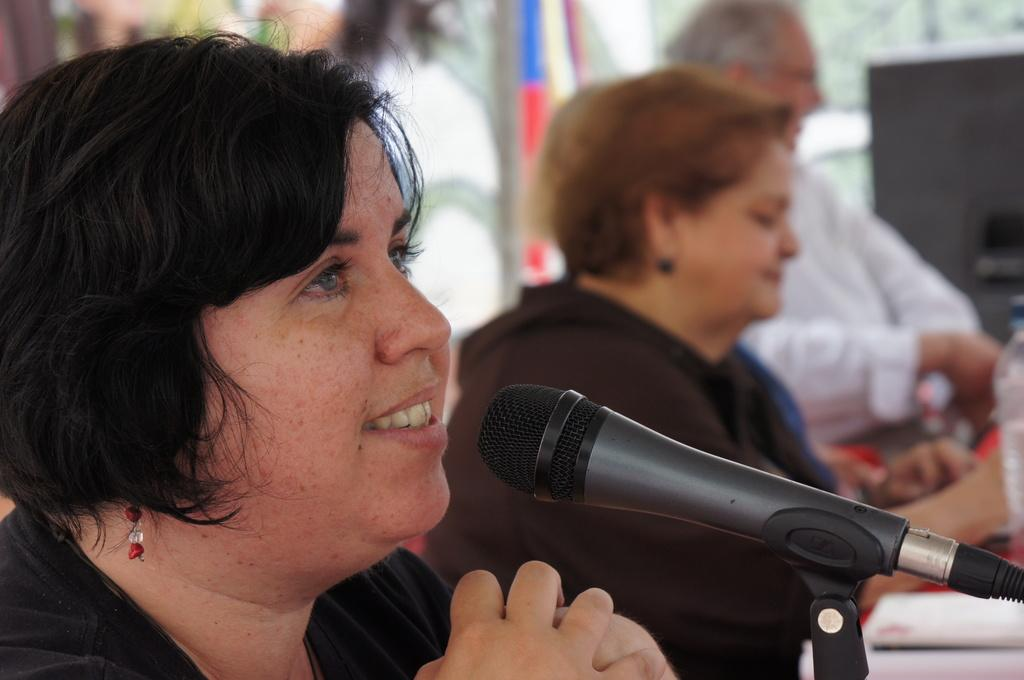Who is present in the image? There is a woman in the image. What is the woman doing in the image? The woman is smiling in the image. What object can be seen near the woman? There is a microphone (mike) in the image. What other item is visible in the image? There is a bottle in the image. How many people are sitting in the image? There are two persons sitting in the image. Can you describe the background of the image? The background of the image is blurred. What type of cart is visible in the image? There is no cart present in the image. Can you describe the face of the jellyfish in the image? There is no jellyfish present in the image. 